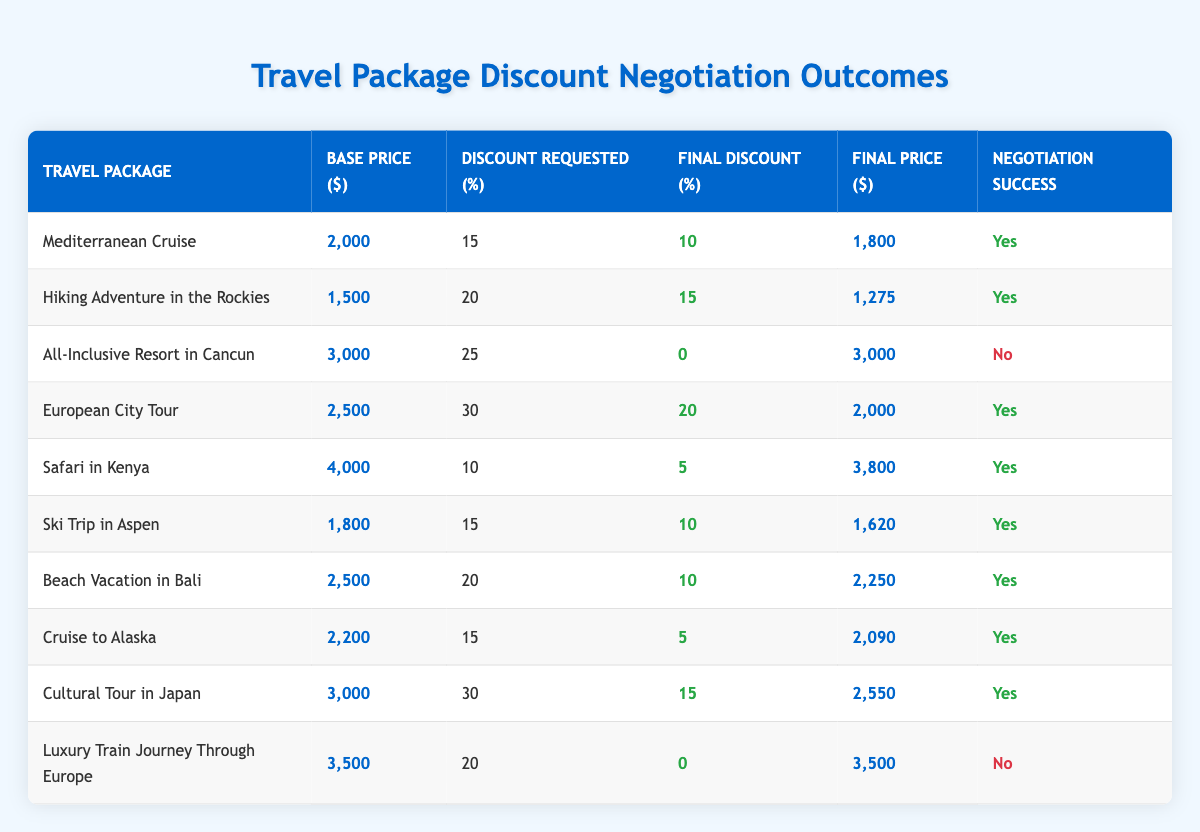What is the base price of the Safari in Kenya travel package? The table lists the base prices for each travel package. For the Safari in Kenya, the base price is found in the respective row under the "Base Price ($)" column. The value listed is 4000.
Answer: 4000 Which travel package had the highest final price? To find the highest final price, we check the "Final Price ($)" column for each package. Upon review, the All-Inclusive Resort in Cancun has the highest final price of 3000.
Answer: 3000 What was the final discount percentage for the European City Tour? The final discount percentage can be found in the "Final Discount (%)" column for the European City Tour travel package. It states that the final discount was 20.
Answer: 20 How much was the total discount requested for the Hiking Adventure in the Rockies and the Beach Vacation in Bali combined? First, locate the discount requested for Hiking Adventure in the Rockies, which is 20. Then, find the discount requested for Beach Vacation in Bali, which is 20 as well. Adding these values together: 20 + 20 = 40.
Answer: 40 Did the Cultural Tour in Japan succeed in its discount negotiation? We check the "Negotiation Success" column for the Cultural Tour in Japan. The table indicates that the negotiation was successful, marked with a "Yes."
Answer: Yes What is the average final price of all the travel packages that had successful negotiations? First, identify the final prices of successful negotiations: Mediterranean Cruise (1800), Hiking Adventure in the Rockies (1275), European City Tour (2000), Safari in Kenya (3800), Ski Trip in Aspen (1620), Beach Vacation in Bali (2250), Cruise to Alaska (2090), Cultural Tour in Japan (2550). Sum these values: 1800 + 1275 + 2000 + 3800 + 1620 + 2250 + 2090 + 2550 = 17385. There are 8 successful negotiations, so divide by 8 to find the average: 17385 / 8 = 2173.125.
Answer: 2173.125 How many travel packages managed to achieve a successful negotiation? In the "Negotiation Success" column, we count the rows that have "Yes." Upon reviewing the table, there are 8 packages with successful negotiations.
Answer: 8 What was the final price of the Luxury Train Journey Through Europe? The final price can be found in the "Final Price ($)" column corresponding to the Luxury Train Journey Through Europe, which states the final price is 3500.
Answer: 3500 